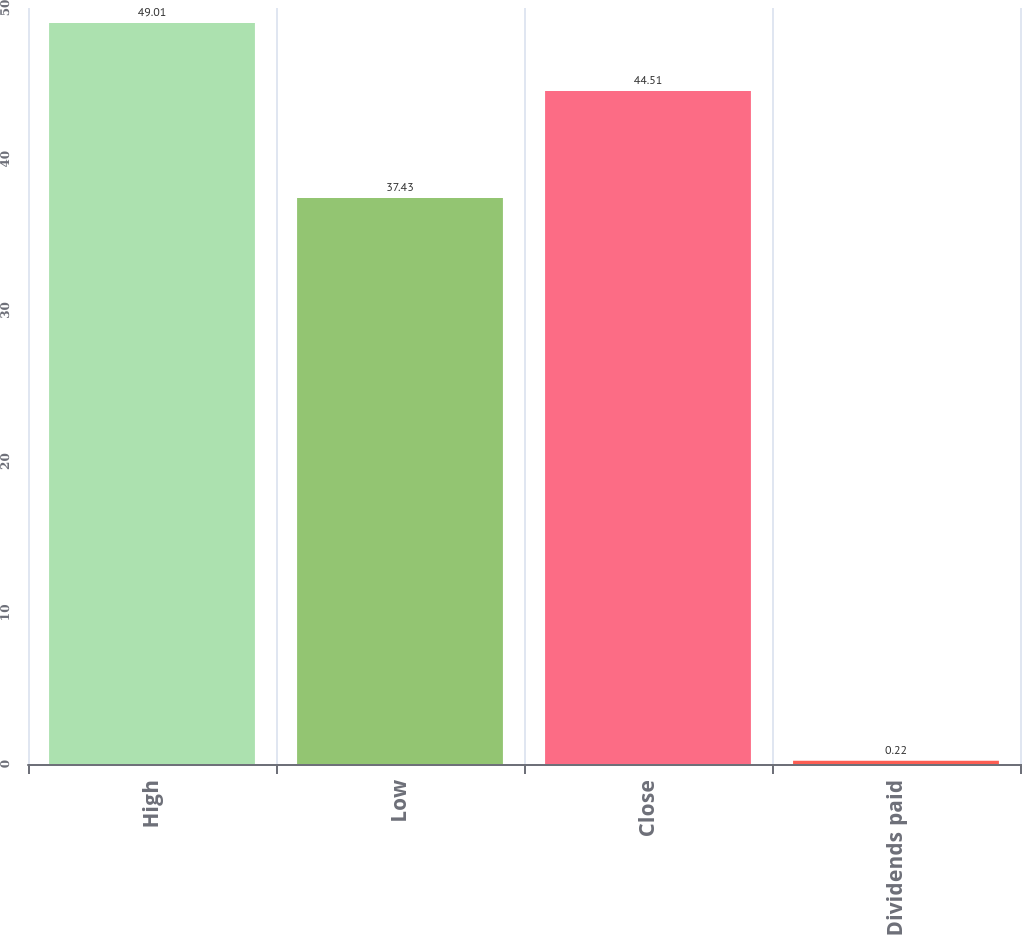Convert chart to OTSL. <chart><loc_0><loc_0><loc_500><loc_500><bar_chart><fcel>High<fcel>Low<fcel>Close<fcel>Dividends paid<nl><fcel>49.01<fcel>37.43<fcel>44.51<fcel>0.22<nl></chart> 